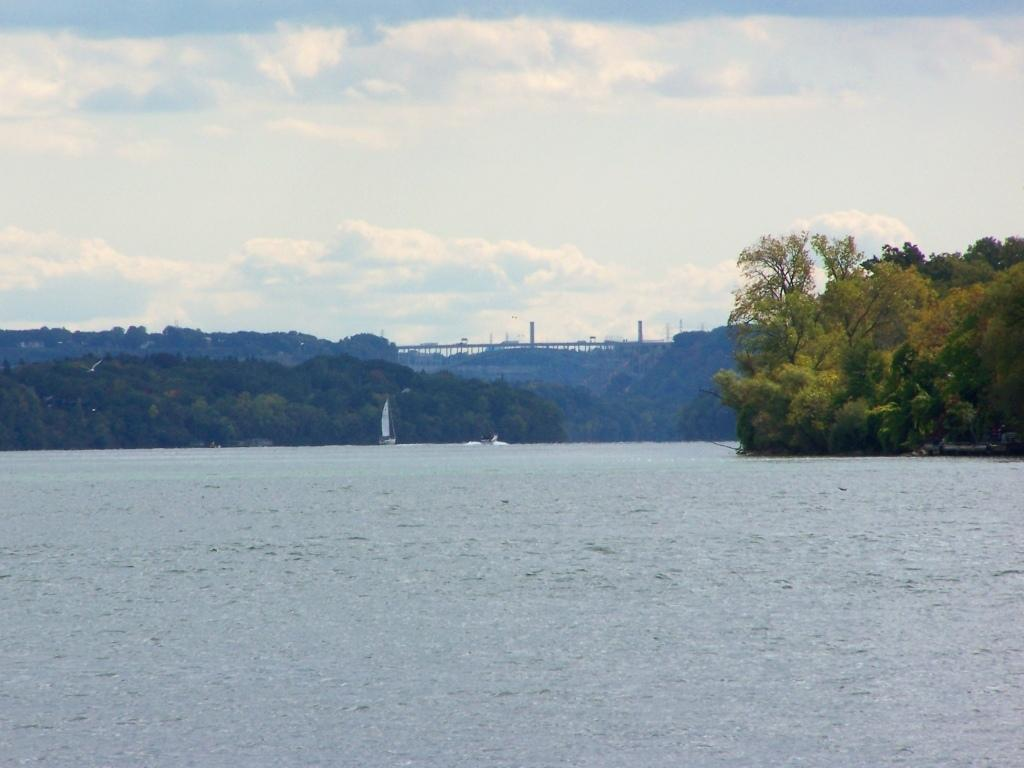What type of natural elements can be seen in the image? There are trees in the image. What man-made structures are present in the image? There are poles in the image. What is floating on the water surface in the image? There are boats on the water surface in the image. What is visible above the trees and boats in the image? The sky is visible in the image. What colors can be observed in the sky in the image? The sky has a combination of white and blue colors in the image. How many cherries are hanging from the trees in the image? There are no cherries present in the image; it features trees, poles, boats, and a sky with a combination of white and blue colors. What type of substance is being balanced on the boats in the image? There is no substance being balanced on the boats in the image; the boats are simply floating on the water surface. 